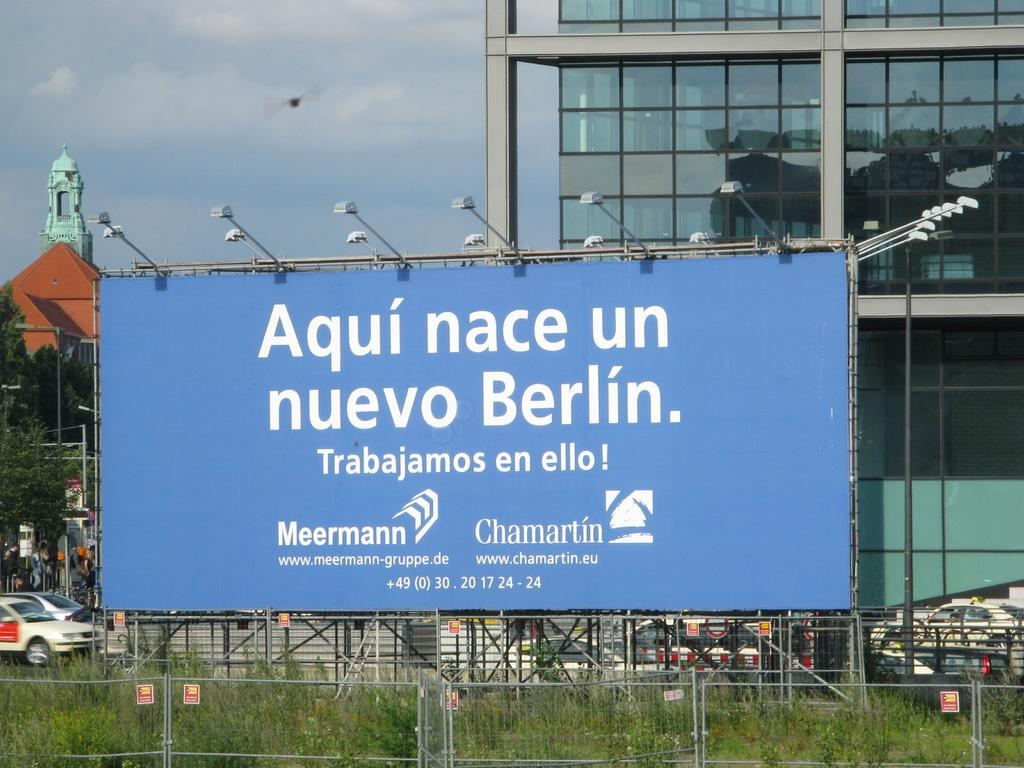What structures can be seen in the image? There are posts, fences, a hoarding, buildings, and street light poles in the image. What type of vegetation is present in the image? There are plants and trees in the image. What objects can be seen related to transportation? There are vehicles in the image. What can be seen in the sky in the background of the image? The sky with clouds is visible in the background of the image. What type of advertisement can be seen on the prison in the image? There is no prison present in the image, and therefore no advertisement can be seen on it. 